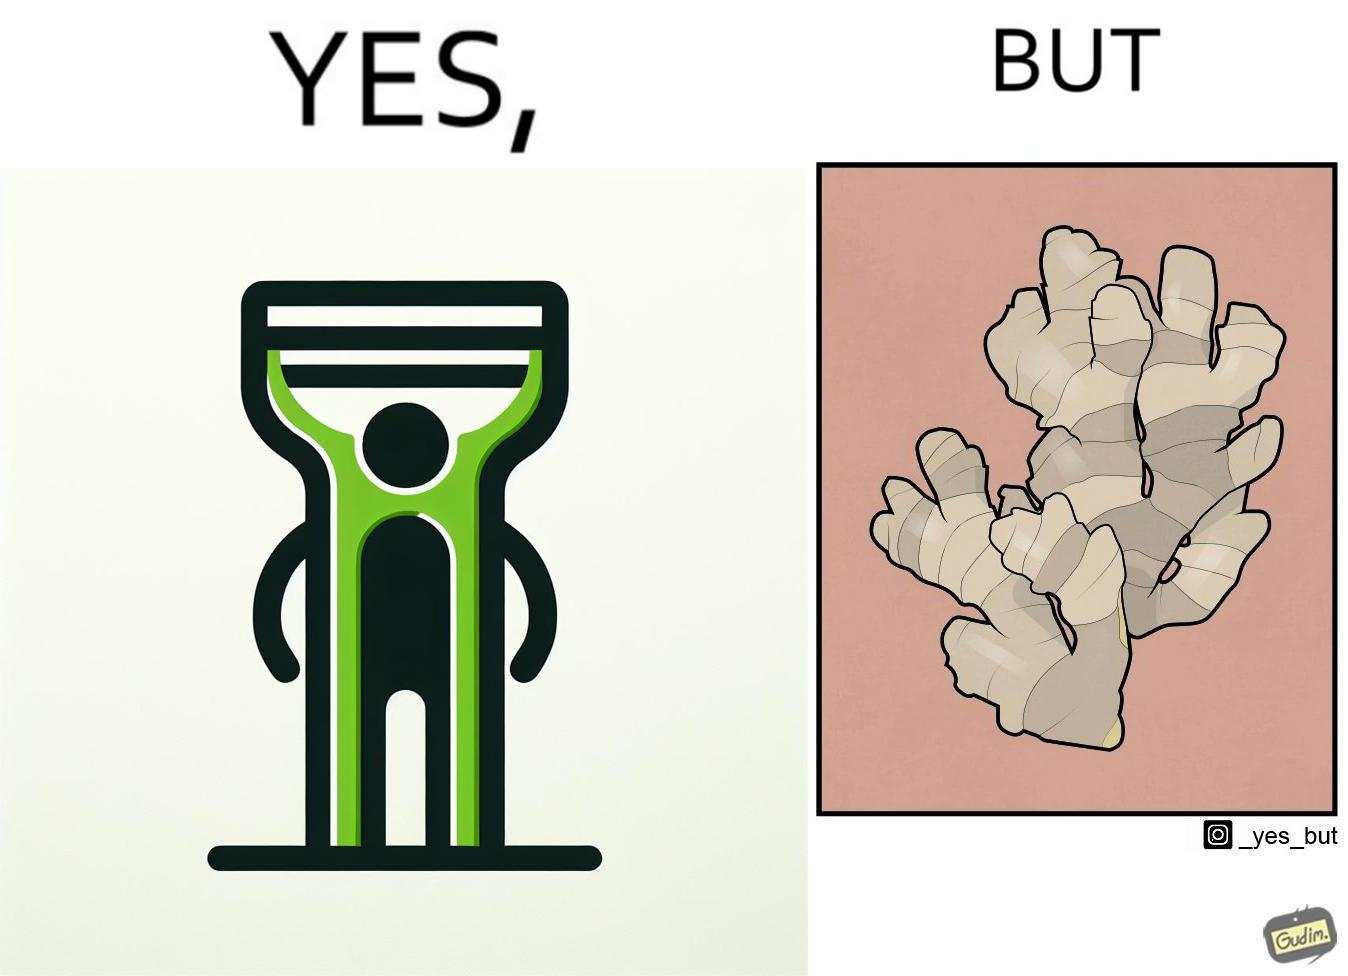What is shown in this image? The image is funny because it suggests that while we have peelers to peel off the skin of many different fruits and vegetables, it is useless against a ginger which has a very complicated shape. 